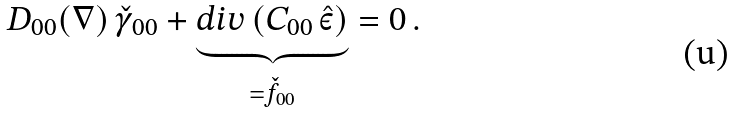<formula> <loc_0><loc_0><loc_500><loc_500>D _ { 0 0 } ( \nabla ) \, \check { \gamma } _ { 0 0 } + \underbrace { d i v \, ( C _ { 0 0 } \, \hat { \varepsilon } ) } _ { = \check { f } _ { 0 0 } } = 0 \, .</formula> 